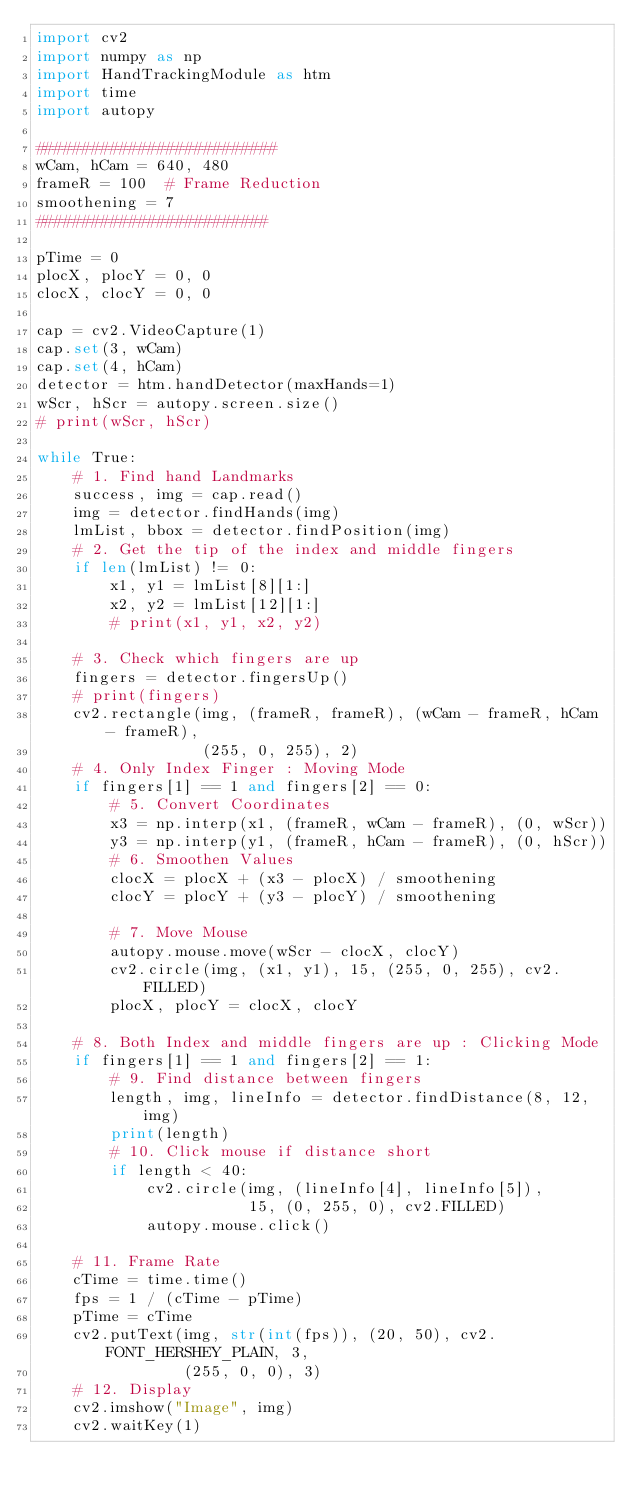<code> <loc_0><loc_0><loc_500><loc_500><_Python_>import cv2
import numpy as np
import HandTrackingModule as htm
import time
import autopy

##########################
wCam, hCam = 640, 480
frameR = 100  # Frame Reduction
smoothening = 7
#########################

pTime = 0
plocX, plocY = 0, 0
clocX, clocY = 0, 0

cap = cv2.VideoCapture(1)
cap.set(3, wCam)
cap.set(4, hCam)
detector = htm.handDetector(maxHands=1)
wScr, hScr = autopy.screen.size()
# print(wScr, hScr)

while True:
    # 1. Find hand Landmarks
    success, img = cap.read()
    img = detector.findHands(img)
    lmList, bbox = detector.findPosition(img)
    # 2. Get the tip of the index and middle fingers
    if len(lmList) != 0:
        x1, y1 = lmList[8][1:]
        x2, y2 = lmList[12][1:]
        # print(x1, y1, x2, y2)

    # 3. Check which fingers are up
    fingers = detector.fingersUp()
    # print(fingers)
    cv2.rectangle(img, (frameR, frameR), (wCam - frameR, hCam - frameR),
                  (255, 0, 255), 2)
    # 4. Only Index Finger : Moving Mode
    if fingers[1] == 1 and fingers[2] == 0:
        # 5. Convert Coordinates
        x3 = np.interp(x1, (frameR, wCam - frameR), (0, wScr))
        y3 = np.interp(y1, (frameR, hCam - frameR), (0, hScr))
        # 6. Smoothen Values
        clocX = plocX + (x3 - plocX) / smoothening
        clocY = plocY + (y3 - plocY) / smoothening

        # 7. Move Mouse
        autopy.mouse.move(wScr - clocX, clocY)
        cv2.circle(img, (x1, y1), 15, (255, 0, 255), cv2.FILLED)
        plocX, plocY = clocX, clocY

    # 8. Both Index and middle fingers are up : Clicking Mode
    if fingers[1] == 1 and fingers[2] == 1:
        # 9. Find distance between fingers
        length, img, lineInfo = detector.findDistance(8, 12, img)
        print(length)
        # 10. Click mouse if distance short
        if length < 40:
            cv2.circle(img, (lineInfo[4], lineInfo[5]),
                       15, (0, 255, 0), cv2.FILLED)
            autopy.mouse.click()

    # 11. Frame Rate
    cTime = time.time()
    fps = 1 / (cTime - pTime)
    pTime = cTime
    cv2.putText(img, str(int(fps)), (20, 50), cv2.FONT_HERSHEY_PLAIN, 3,
                (255, 0, 0), 3)
    # 12. Display
    cv2.imshow("Image", img)
    cv2.waitKey(1)

</code> 